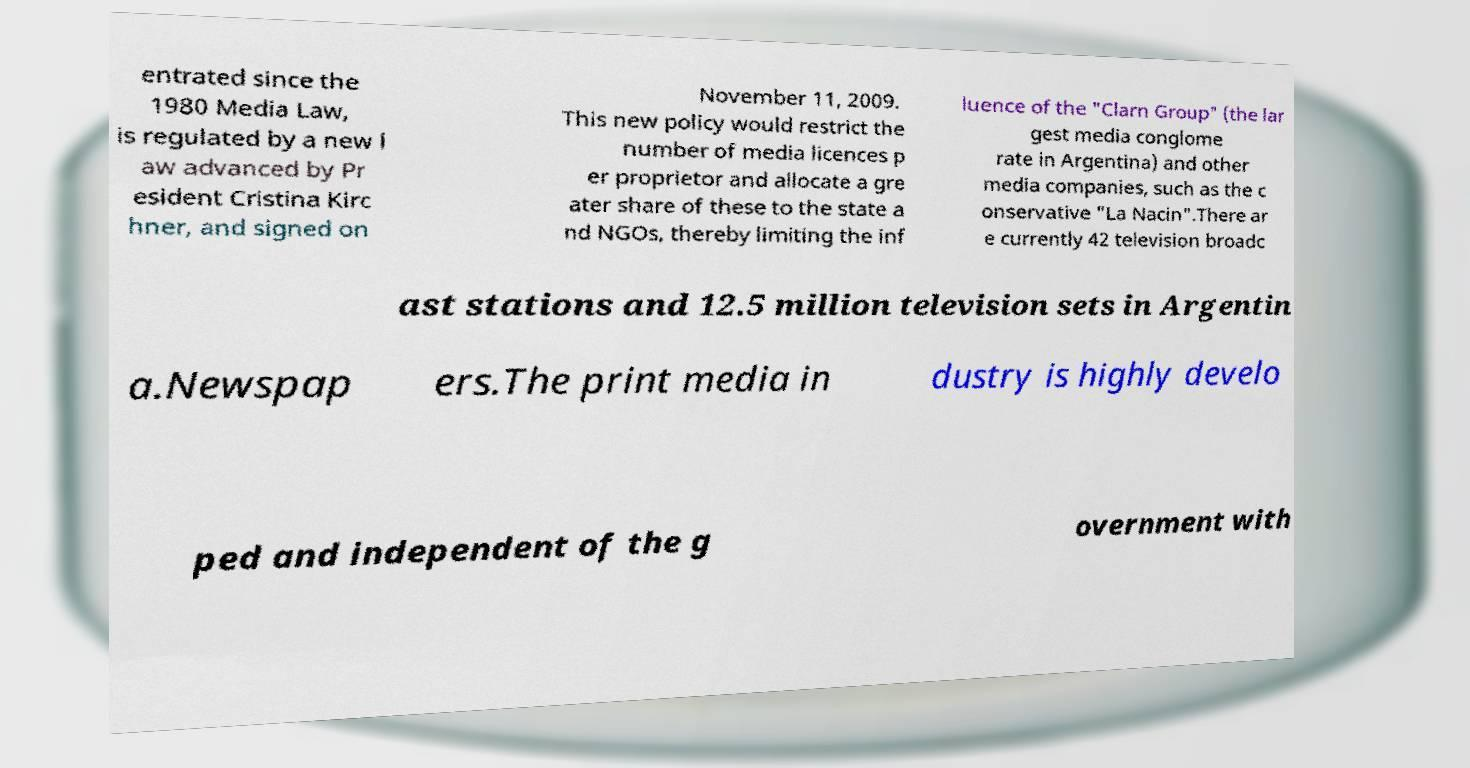Could you assist in decoding the text presented in this image and type it out clearly? entrated since the 1980 Media Law, is regulated by a new l aw advanced by Pr esident Cristina Kirc hner, and signed on November 11, 2009. This new policy would restrict the number of media licences p er proprietor and allocate a gre ater share of these to the state a nd NGOs, thereby limiting the inf luence of the "Clarn Group" (the lar gest media conglome rate in Argentina) and other media companies, such as the c onservative "La Nacin".There ar e currently 42 television broadc ast stations and 12.5 million television sets in Argentin a.Newspap ers.The print media in dustry is highly develo ped and independent of the g overnment with 